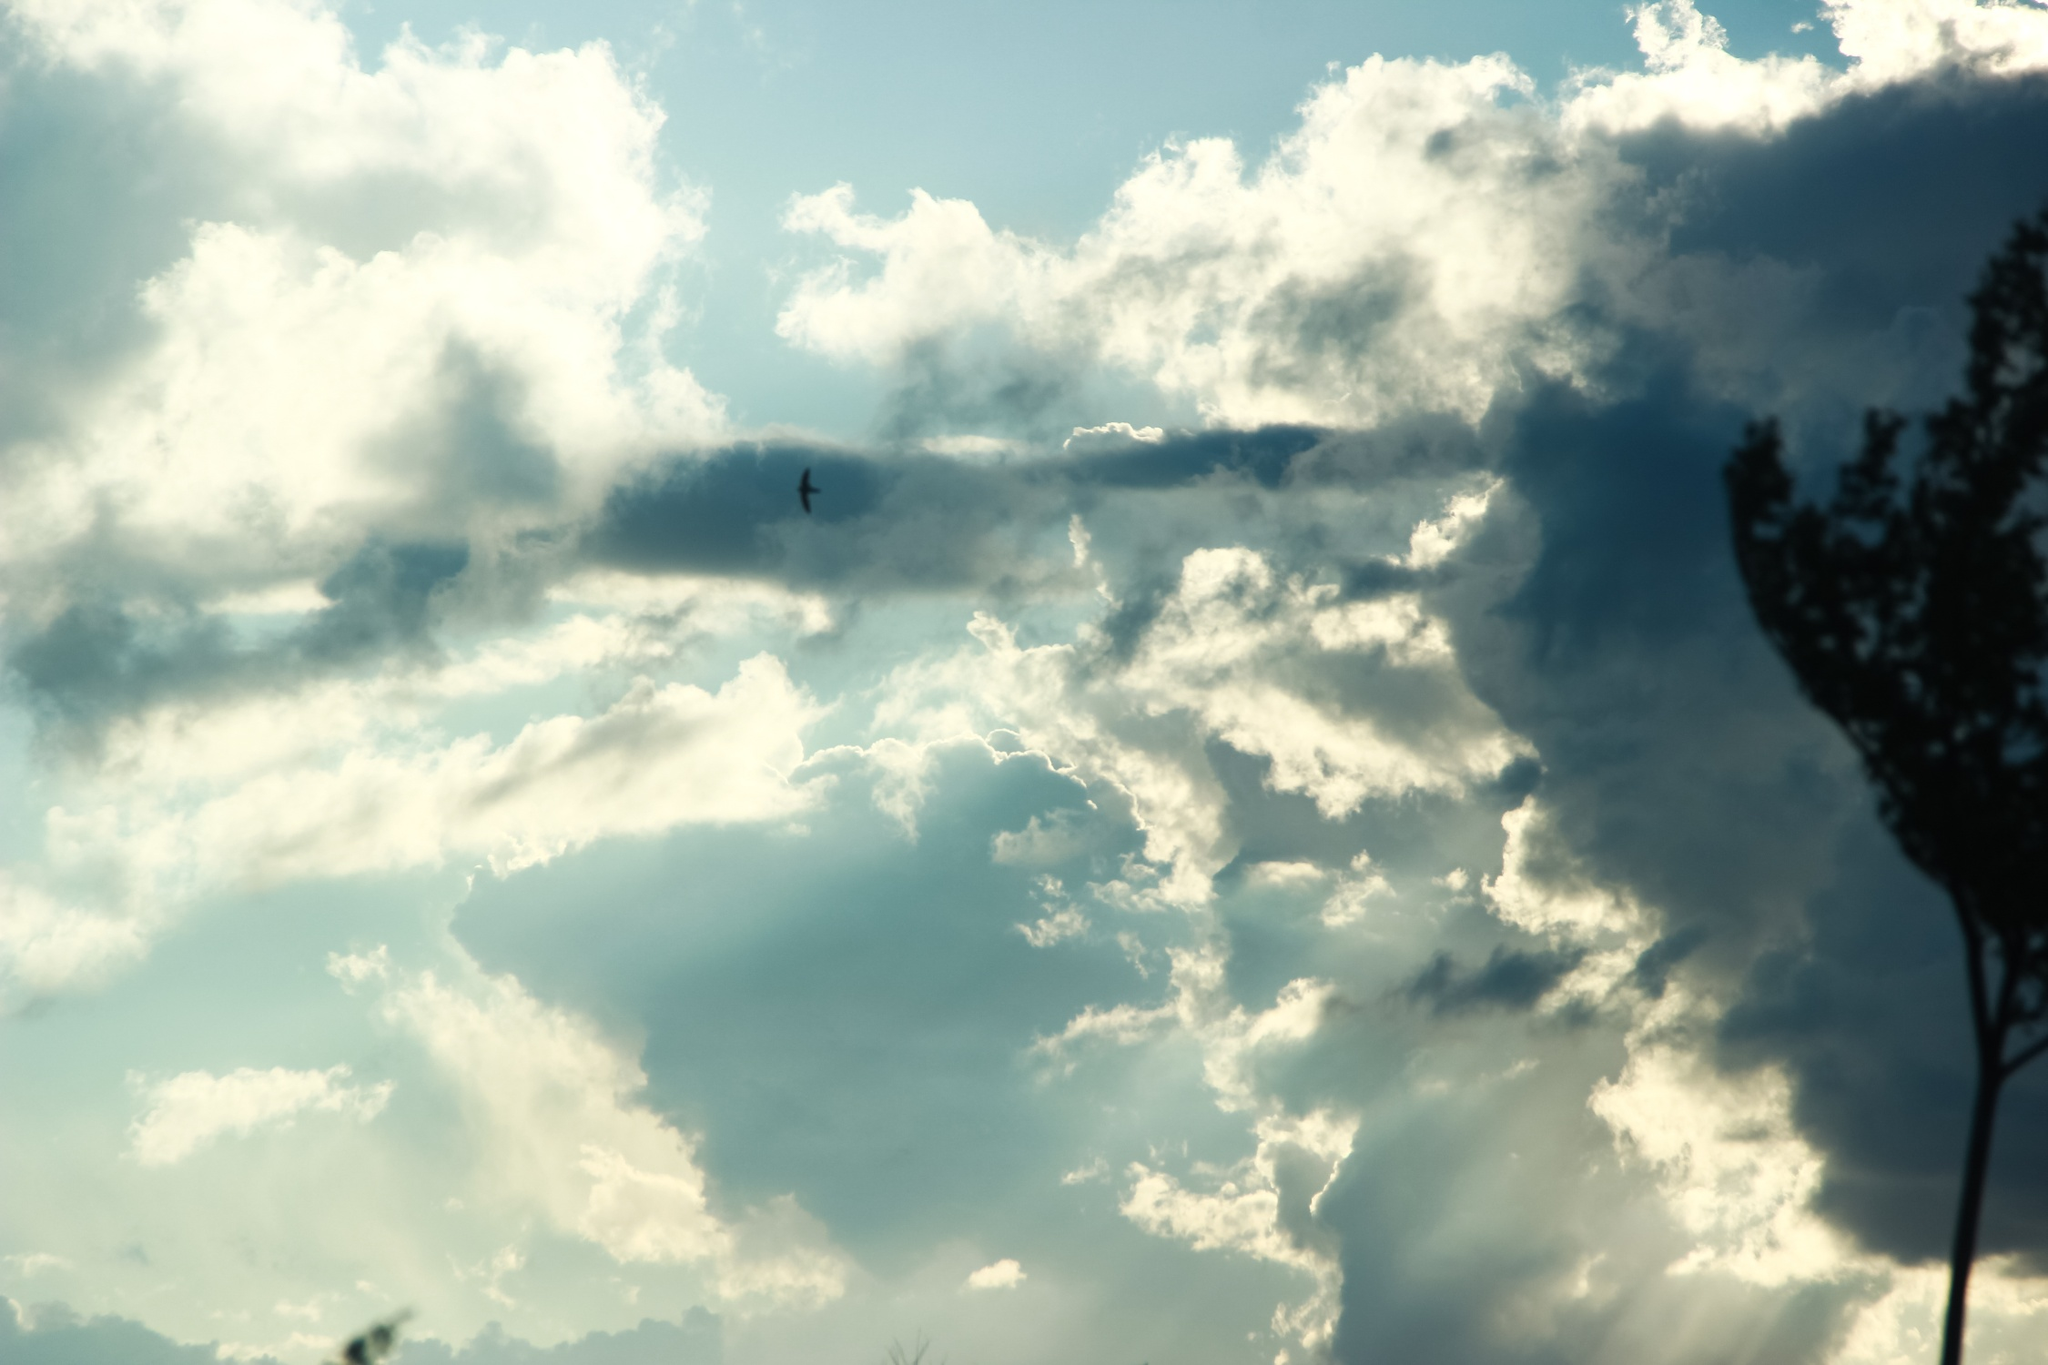How might an artist interpret this scene? An artist might see this scene as a powerful representation of the delicate balance and harmony within nature. The juxtaposition of the dark silhouette of the tree against the vast, luminous sky could be interpreted as a contrast between strength and fragility. The presence of the small bird in flight might be seen as a symbol of freedom and life, adding a dynamic element to the otherwise tranquil scene. The artist could use various techniques such as light and shadow, color gradients, and texture to capture the ethereal quality of the clouds and the aged resilience of the tree. They might even choose to emphasize the perspective, drawing the viewer's eye upwards to highlight the grandeur of the sky and the feeling of upliftment. Through the interplay of these elements, the artist would seek to evoke emotions of peace, contemplation, and an appreciation for the quiet beauty of the natural world. 